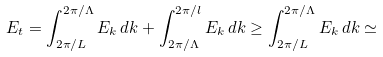<formula> <loc_0><loc_0><loc_500><loc_500>E _ { t } = \int _ { 2 \pi / L } ^ { 2 \pi / \Lambda } E _ { k } \, d k + \int _ { 2 \pi / \Lambda } ^ { 2 \pi / l } E _ { k } \, d k \geq \int _ { 2 \pi / L } ^ { 2 \pi / \Lambda } E _ { k } \, d k \simeq</formula> 